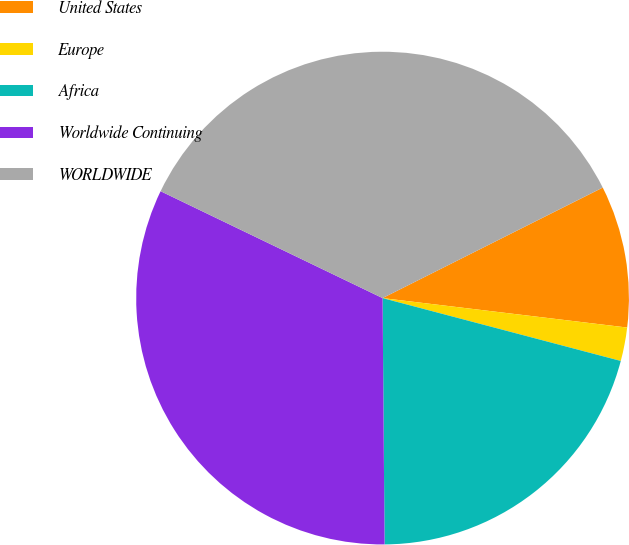Convert chart. <chart><loc_0><loc_0><loc_500><loc_500><pie_chart><fcel>United States<fcel>Europe<fcel>Africa<fcel>Worldwide Continuing<fcel>WORLDWIDE<nl><fcel>9.31%<fcel>2.2%<fcel>20.76%<fcel>32.27%<fcel>35.45%<nl></chart> 